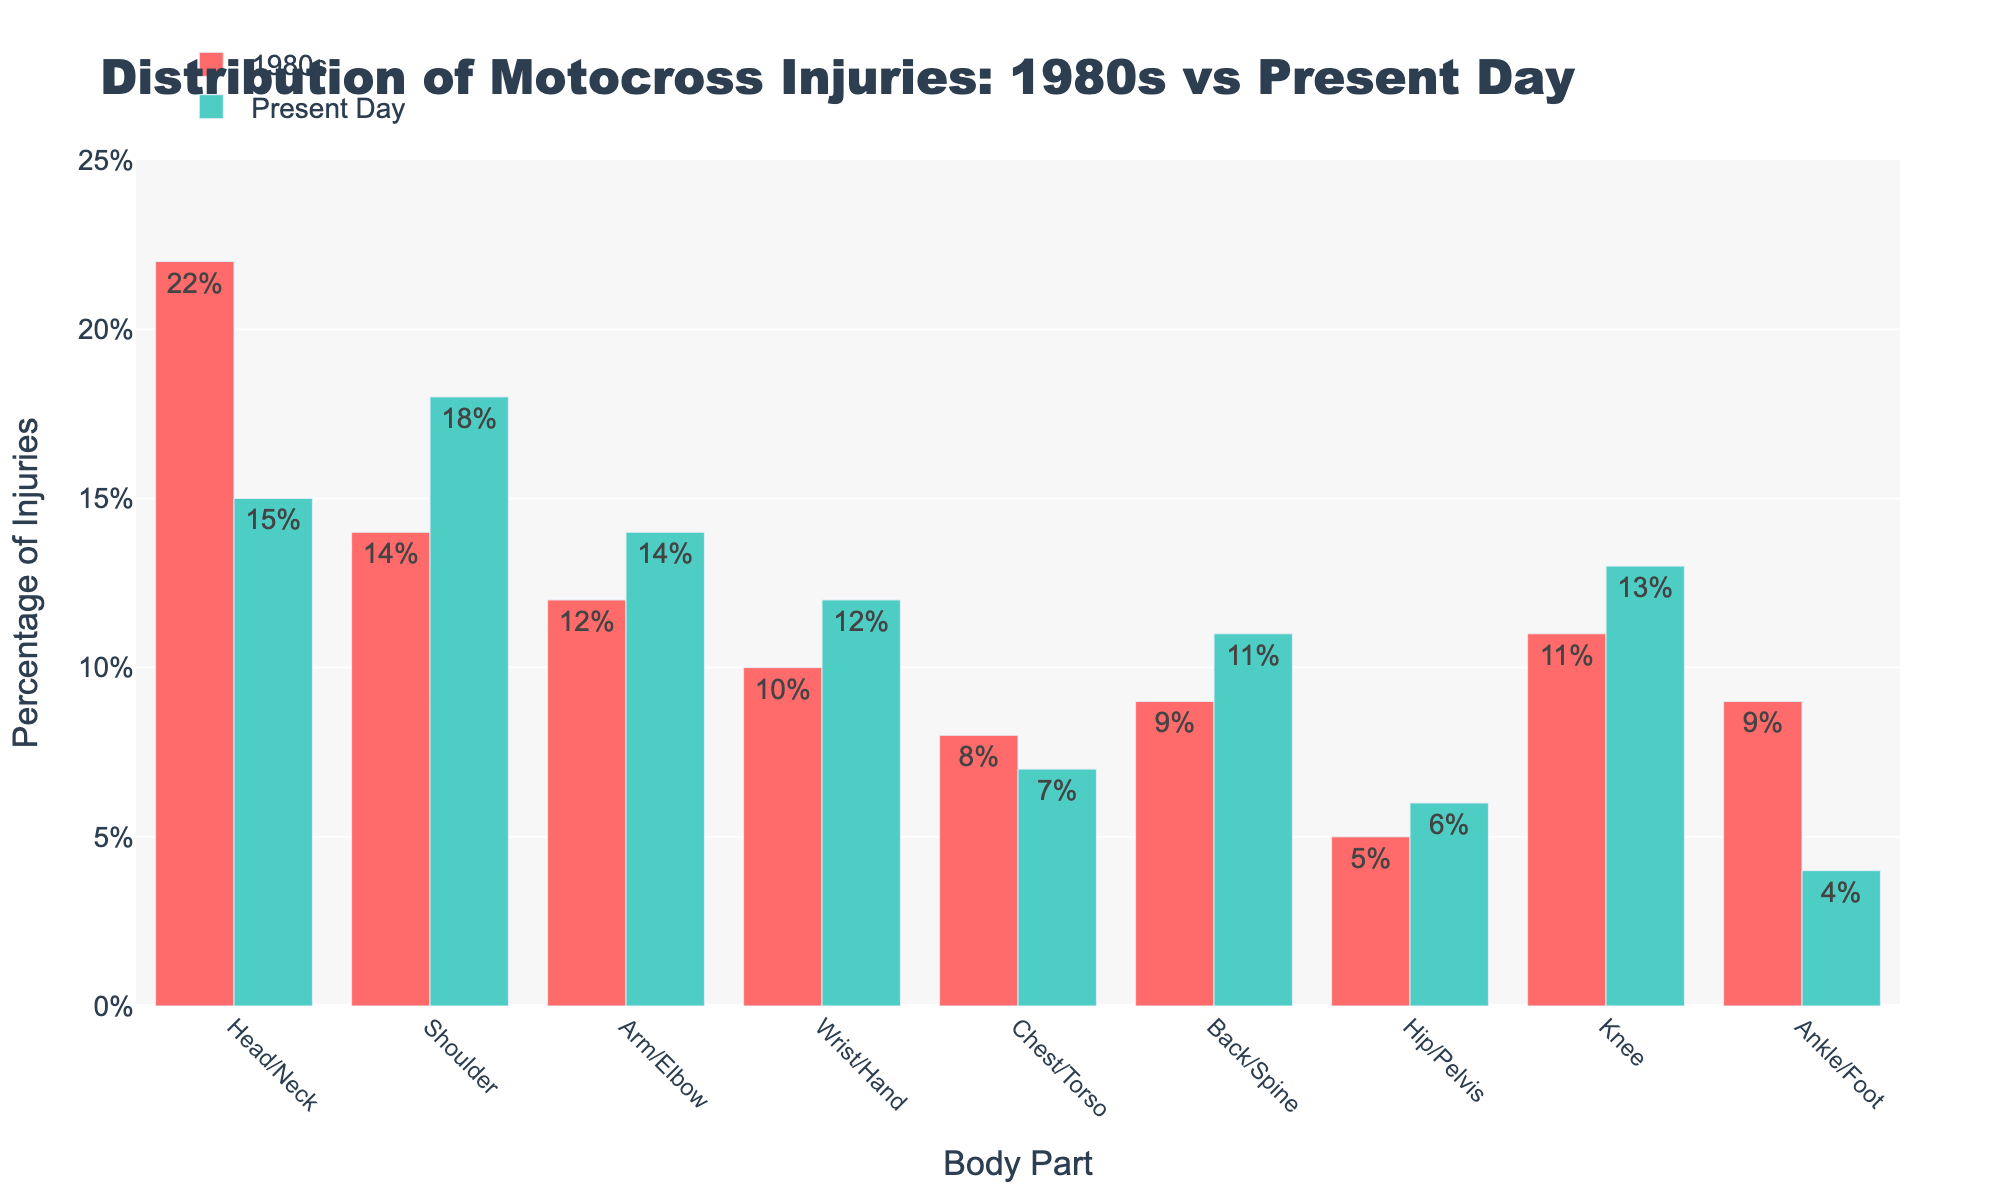Which body part has seen the largest decrease in injury percentage from the 1980s to the present day? To find the largest decrease, subtract the present-day percentage from the 1980s percentage for each body part. The decreases are: Head/Neck (7%), Shoulder (-4%), Arm/Elbow (-2%), Wrist/Hand (-2%), Chest/Torso (1%), Back/Spine (-2%), Hip/Pelvis (-1%), Knee (-2%), Ankle/Foot (5%). The largest decrease is for Head/Neck (7%).
Answer: Head/Neck Which body part has the highest percentage of injuries in the present day? Compare the percentages of all body parts in the present day column. The highest value is 18% for Shoulder.
Answer: Shoulder Which body part has seen an increase in injury percentage from the 1980s to the present day? Look for positive differences between the 1980s and present-day percentages: Shoulder (4%), Arm/Elbow (2%), Wrist/Hand (2%), Back/Spine (2%), Hip/Pelvis (1%), Knee (2%). These parts have shown an increase.
Answer: Shoulder, Arm/Elbow, Wrist/Hand, Back/Spine, Hip/Pelvis, Knee What's the total percentage of injuries for all body parts in the 1980s? Sum the percentages for all body parts in the 1980s: 22 + 14 + 12 + 10 + 8 + 9 + 5 + 11 + 9 = 100.
Answer: 100% How has the percentage of ankle/foot injuries changed from the 1980s to the present day? Subtract the present-day percentage from the 1980s percentage for ankle/foot: 9 - 4 = 5. The percentage has decreased by 5%.
Answer: Decreased by 5% Which body part had a higher injury percentage in the 1980s compared to present day, except for Head/Neck? Compare the present day and 1980s percentages for body parts: Shoulder (-4), Arm/Elbow (-2), Wrist/Hand (-2), Chest/Torso (1), Back/Spine (-2), Hip/Pelvis (-1), Knee (-2), Ankle/Foot (5). Only Ankle/Foot had a higher percentage in the 1980s.
Answer: Ankle/Foot What is the combined percentage of Shoulder and Knee injuries in the present day? Sum the present day percentages of Shoulder (18%) and Knee (13%): 18 + 13 = 31.
Answer: 31% By what percentage did Chest/Torso injuries change from the 1980s to the present day? Subtract the present-day percentage from the 1980s percentage for Chest/Torso: 8 - 7 = 1. The percentage has decreased by 1%.
Answer: Decreased by 1% Which body part has both 12% injuries in the present day and saw an increase from the 1980s? Check for the body part with 12% in the present day and an increase from the 1980s: Wrist/Hand (10 to 12, increase of 2).
Answer: Wrist/Hand What is the total percentage of injuries for Shoulder and Arm/Elbow combined across both the 1980s and the present day? Sum the percentages of Shoulder and Arm/Elbow for both periods: 14 + 12 (1980s) and 18 + 14 (present day) = 28 (1980s) + 32 (present day) = 60%.
Answer: 60% 